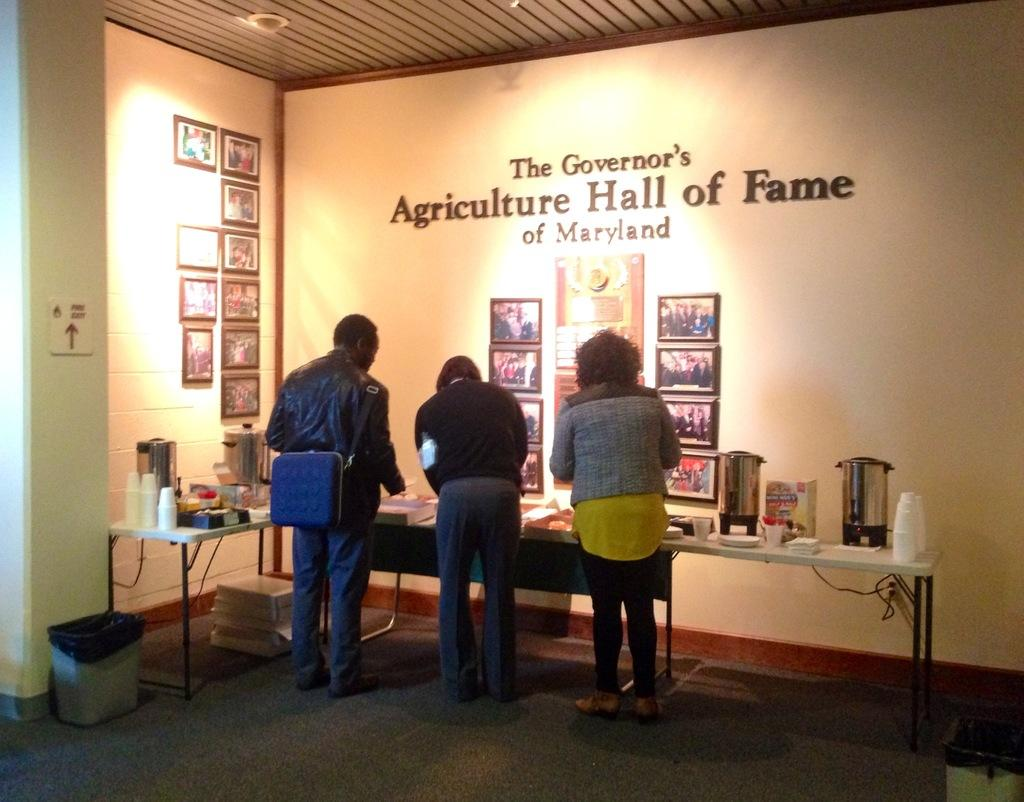<image>
Share a concise interpretation of the image provided. People standing in front of words that says "Agriculture Hall of Fame" on the wall. 